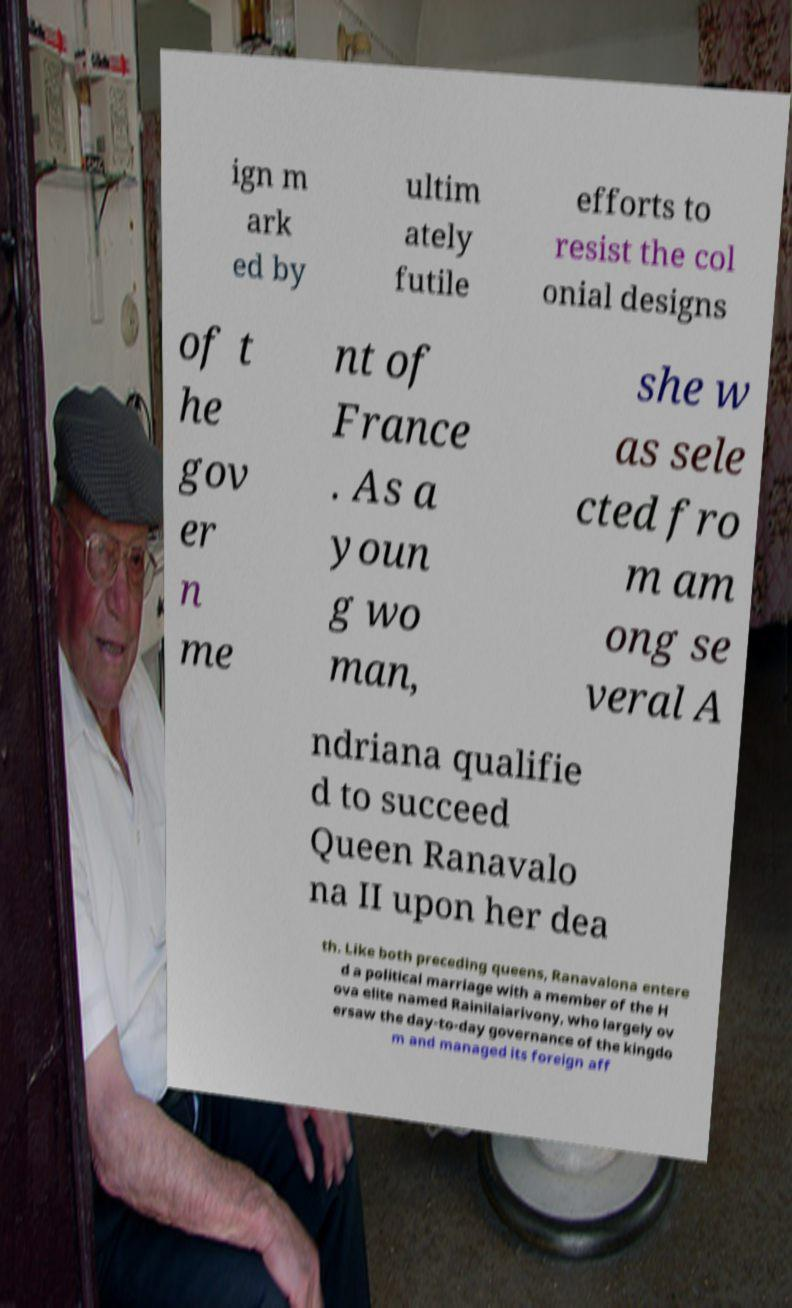I need the written content from this picture converted into text. Can you do that? ign m ark ed by ultim ately futile efforts to resist the col onial designs of t he gov er n me nt of France . As a youn g wo man, she w as sele cted fro m am ong se veral A ndriana qualifie d to succeed Queen Ranavalo na II upon her dea th. Like both preceding queens, Ranavalona entere d a political marriage with a member of the H ova elite named Rainilaiarivony, who largely ov ersaw the day-to-day governance of the kingdo m and managed its foreign aff 